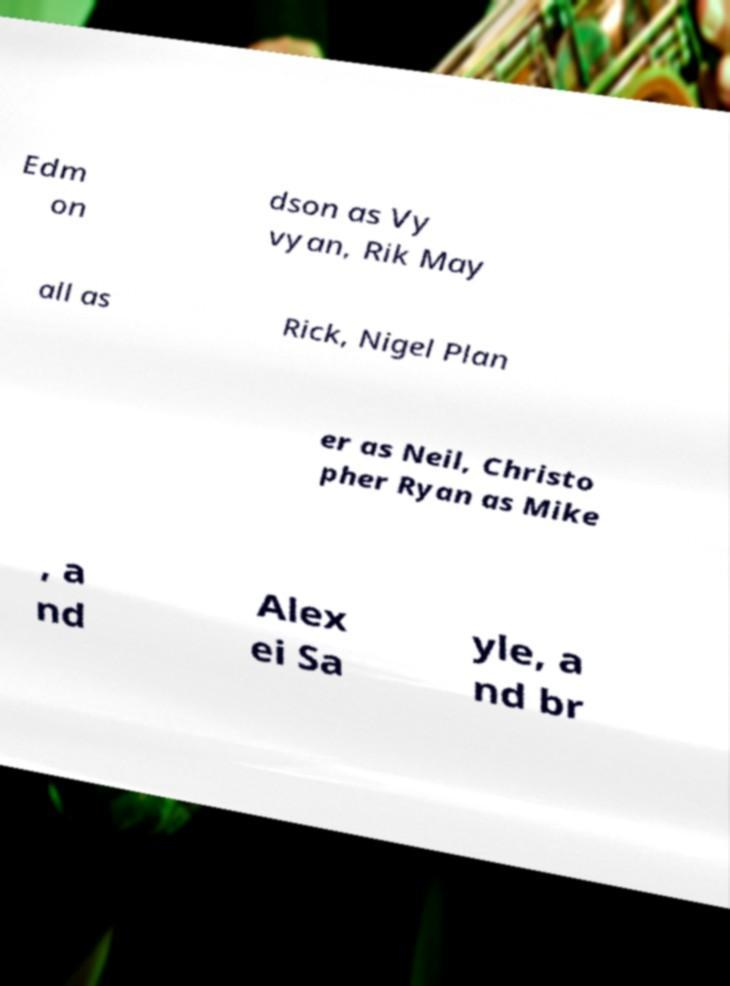There's text embedded in this image that I need extracted. Can you transcribe it verbatim? Edm on dson as Vy vyan, Rik May all as Rick, Nigel Plan er as Neil, Christo pher Ryan as Mike , a nd Alex ei Sa yle, a nd br 